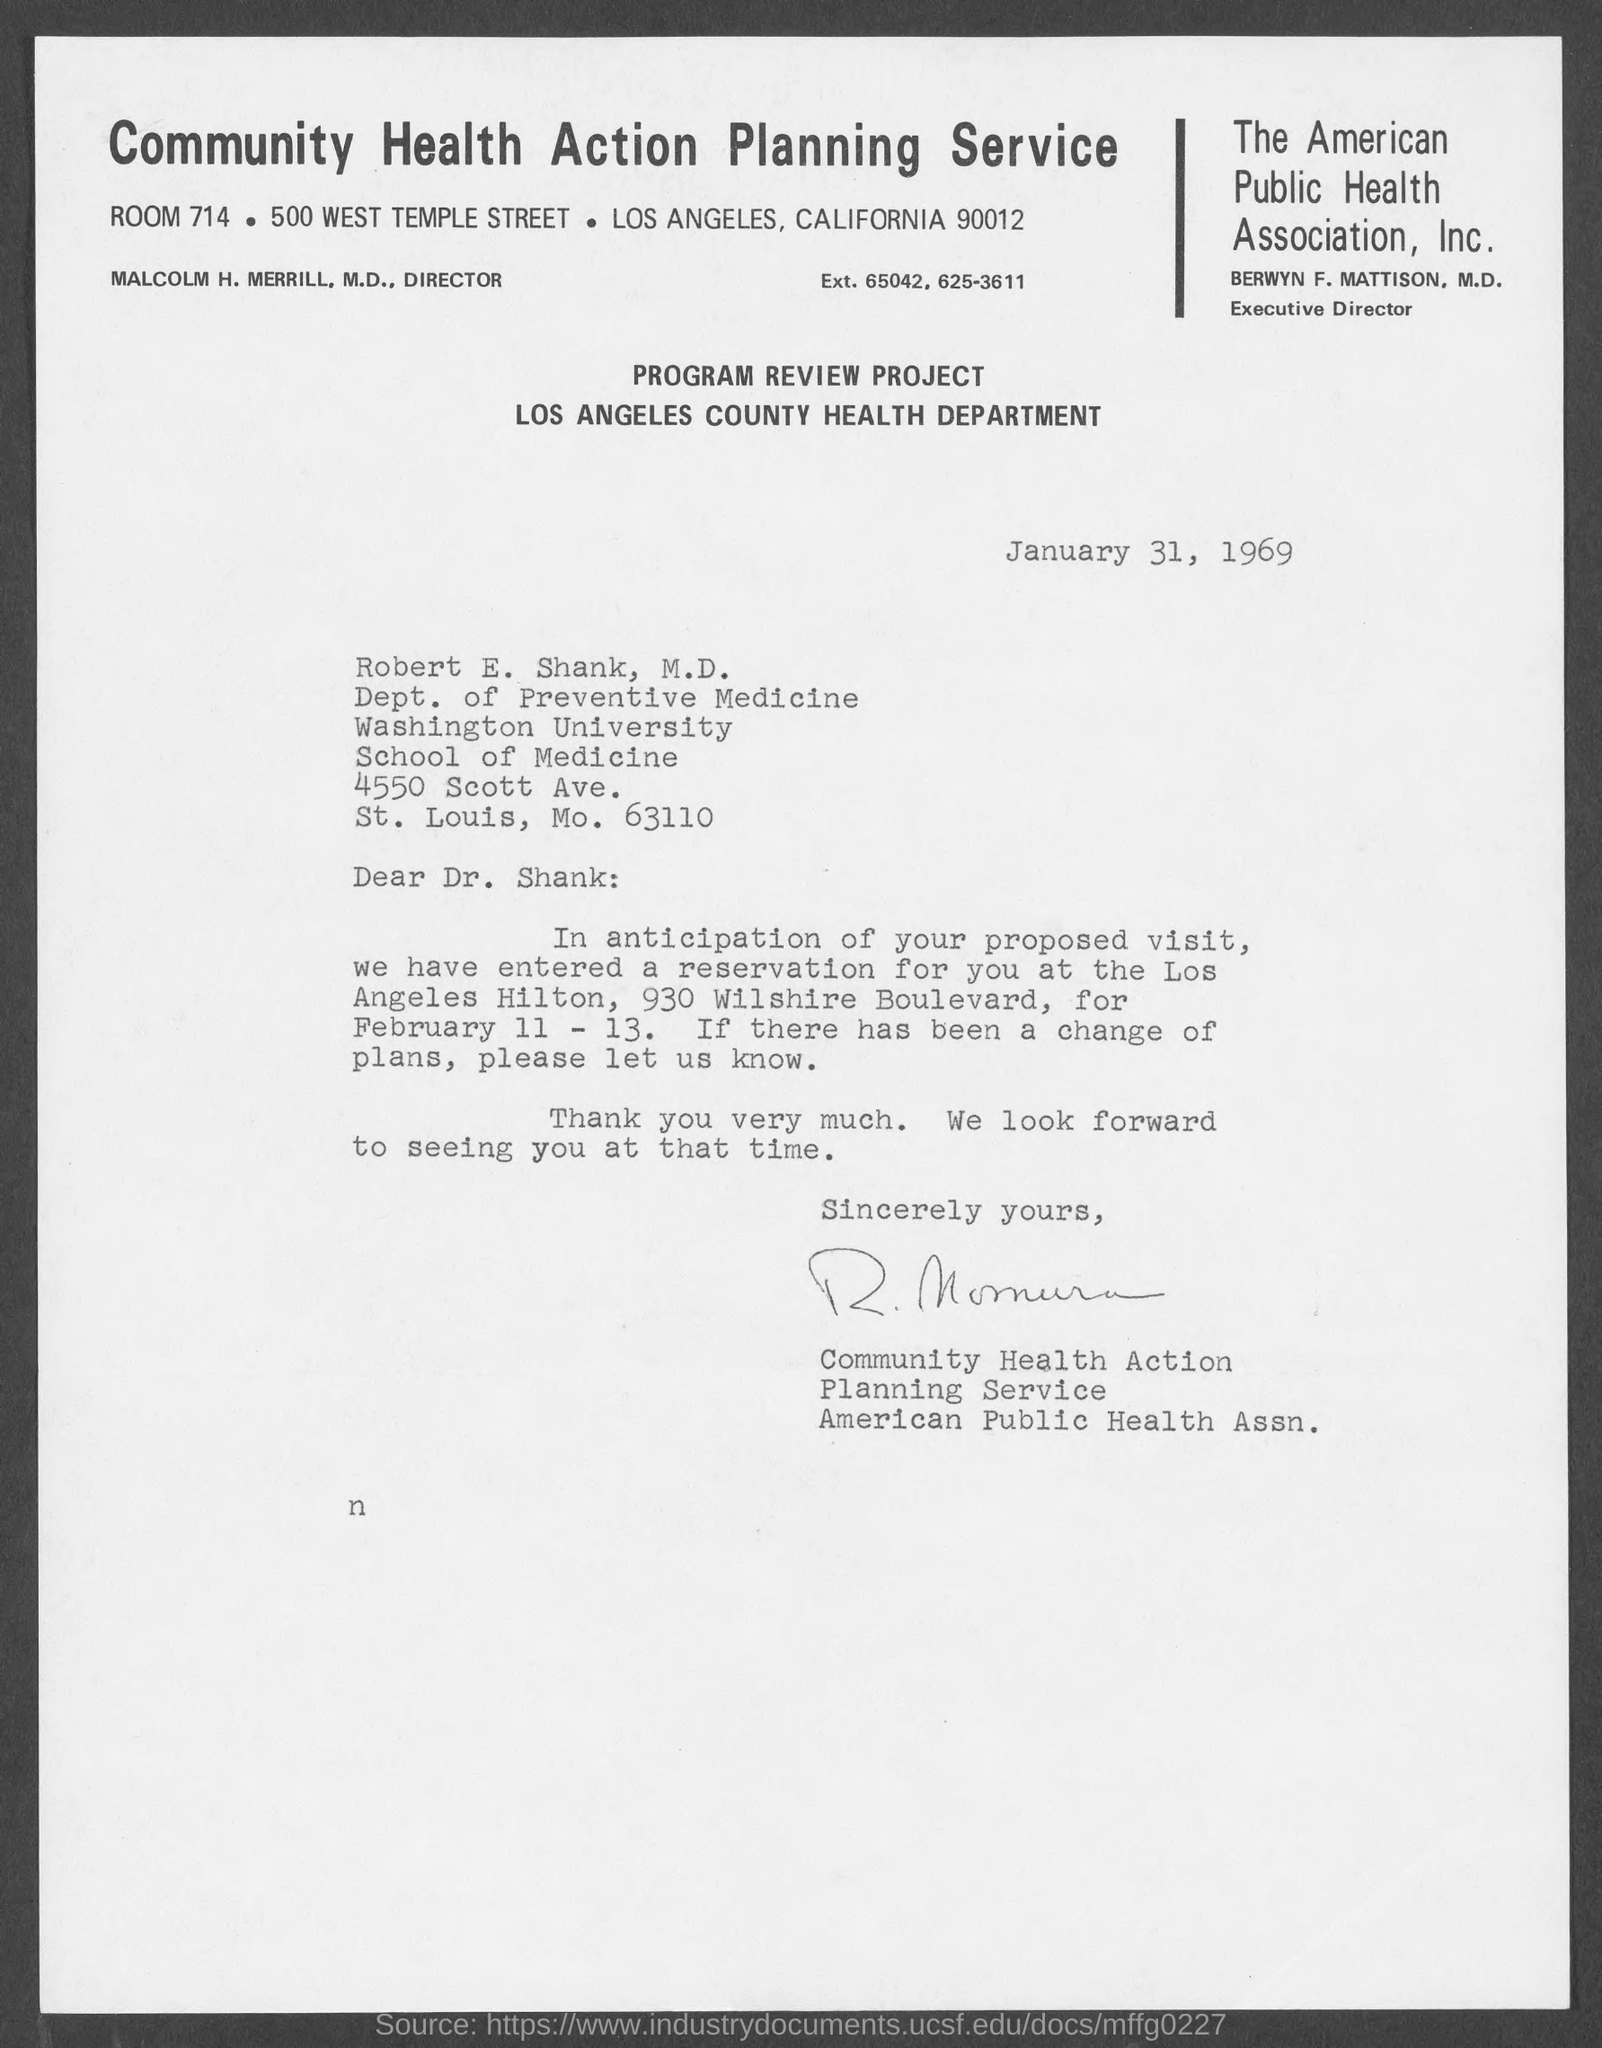What is the name of the public health association?
Your answer should be compact. The American Publich Health Association, Inc. What is the Room Number  of community health action planning service?
Provide a short and direct response. Room 714. Who is the Executive Director ?
Offer a very short reply. BERWYN F. MATTISON, M.D. On what date is this letter written?
Provide a succinct answer. January 31,1969. 